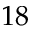Convert formula to latex. <formula><loc_0><loc_0><loc_500><loc_500>1 8</formula> 